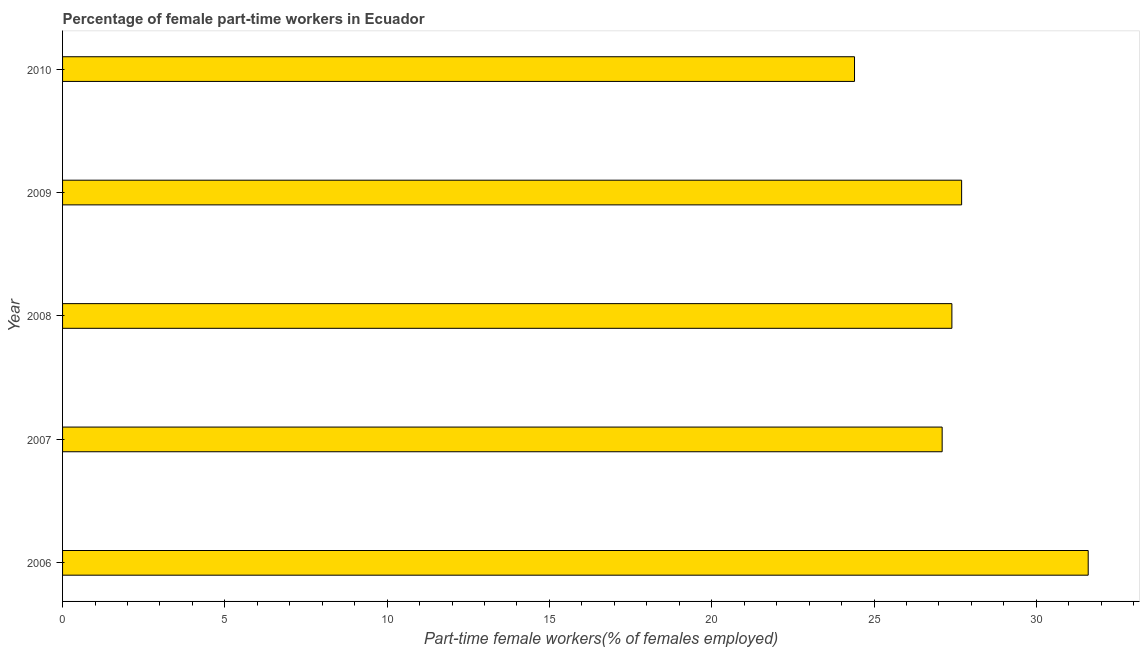Does the graph contain any zero values?
Provide a succinct answer. No. What is the title of the graph?
Provide a short and direct response. Percentage of female part-time workers in Ecuador. What is the label or title of the X-axis?
Keep it short and to the point. Part-time female workers(% of females employed). What is the label or title of the Y-axis?
Ensure brevity in your answer.  Year. What is the percentage of part-time female workers in 2008?
Provide a short and direct response. 27.4. Across all years, what is the maximum percentage of part-time female workers?
Ensure brevity in your answer.  31.6. Across all years, what is the minimum percentage of part-time female workers?
Keep it short and to the point. 24.4. What is the sum of the percentage of part-time female workers?
Give a very brief answer. 138.2. What is the difference between the percentage of part-time female workers in 2006 and 2008?
Offer a terse response. 4.2. What is the average percentage of part-time female workers per year?
Provide a short and direct response. 27.64. What is the median percentage of part-time female workers?
Your answer should be compact. 27.4. In how many years, is the percentage of part-time female workers greater than 4 %?
Offer a terse response. 5. Do a majority of the years between 2008 and 2009 (inclusive) have percentage of part-time female workers greater than 31 %?
Ensure brevity in your answer.  No. What is the difference between the highest and the second highest percentage of part-time female workers?
Offer a very short reply. 3.9. How many bars are there?
Give a very brief answer. 5. Are all the bars in the graph horizontal?
Your response must be concise. Yes. What is the difference between two consecutive major ticks on the X-axis?
Ensure brevity in your answer.  5. Are the values on the major ticks of X-axis written in scientific E-notation?
Give a very brief answer. No. What is the Part-time female workers(% of females employed) in 2006?
Provide a succinct answer. 31.6. What is the Part-time female workers(% of females employed) in 2007?
Offer a very short reply. 27.1. What is the Part-time female workers(% of females employed) in 2008?
Provide a short and direct response. 27.4. What is the Part-time female workers(% of females employed) in 2009?
Offer a very short reply. 27.7. What is the Part-time female workers(% of females employed) of 2010?
Your answer should be compact. 24.4. What is the difference between the Part-time female workers(% of females employed) in 2006 and 2007?
Make the answer very short. 4.5. What is the difference between the Part-time female workers(% of females employed) in 2006 and 2009?
Your response must be concise. 3.9. What is the difference between the Part-time female workers(% of females employed) in 2008 and 2010?
Give a very brief answer. 3. What is the difference between the Part-time female workers(% of females employed) in 2009 and 2010?
Offer a terse response. 3.3. What is the ratio of the Part-time female workers(% of females employed) in 2006 to that in 2007?
Make the answer very short. 1.17. What is the ratio of the Part-time female workers(% of females employed) in 2006 to that in 2008?
Offer a very short reply. 1.15. What is the ratio of the Part-time female workers(% of females employed) in 2006 to that in 2009?
Give a very brief answer. 1.14. What is the ratio of the Part-time female workers(% of females employed) in 2006 to that in 2010?
Ensure brevity in your answer.  1.29. What is the ratio of the Part-time female workers(% of females employed) in 2007 to that in 2009?
Make the answer very short. 0.98. What is the ratio of the Part-time female workers(% of females employed) in 2007 to that in 2010?
Provide a short and direct response. 1.11. What is the ratio of the Part-time female workers(% of females employed) in 2008 to that in 2009?
Your answer should be compact. 0.99. What is the ratio of the Part-time female workers(% of females employed) in 2008 to that in 2010?
Keep it short and to the point. 1.12. What is the ratio of the Part-time female workers(% of females employed) in 2009 to that in 2010?
Provide a succinct answer. 1.14. 